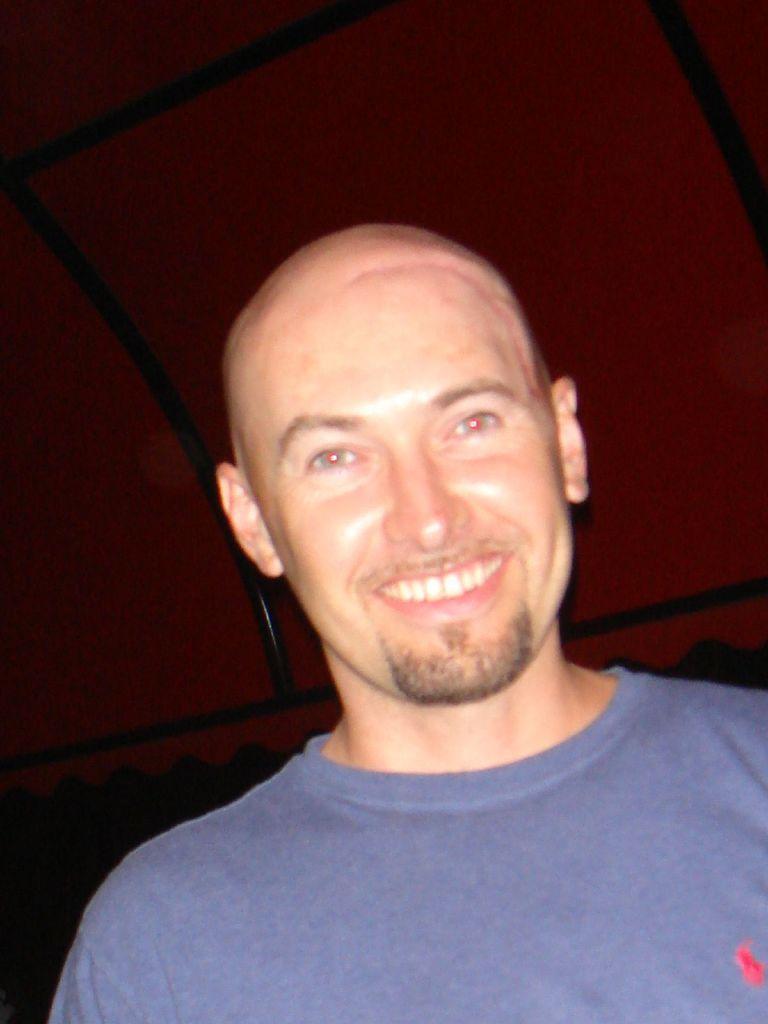How would you summarize this image in a sentence or two? This is a zoomed in picture. In the foreground there is a man wearing blue color t-shirt and smiling. In the background there is a red color object seems to be the roof of a tent and we can see the metal rods. 